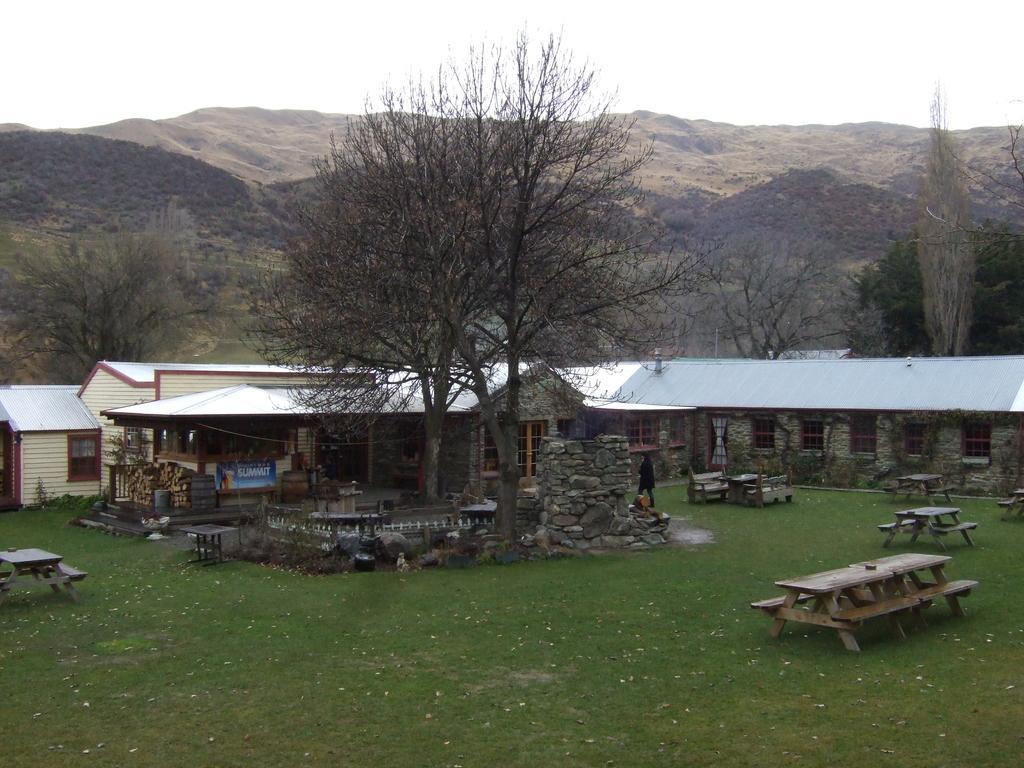In one or two sentences, can you explain what this image depicts? In the center of the image we can see a person standing on the grass field, stone wall, building with windows and a sign board with some text. In the foreground we can see some benches, table and a vessel placed on the ground. In the background, we can see a group of trees, hills and the sky. 